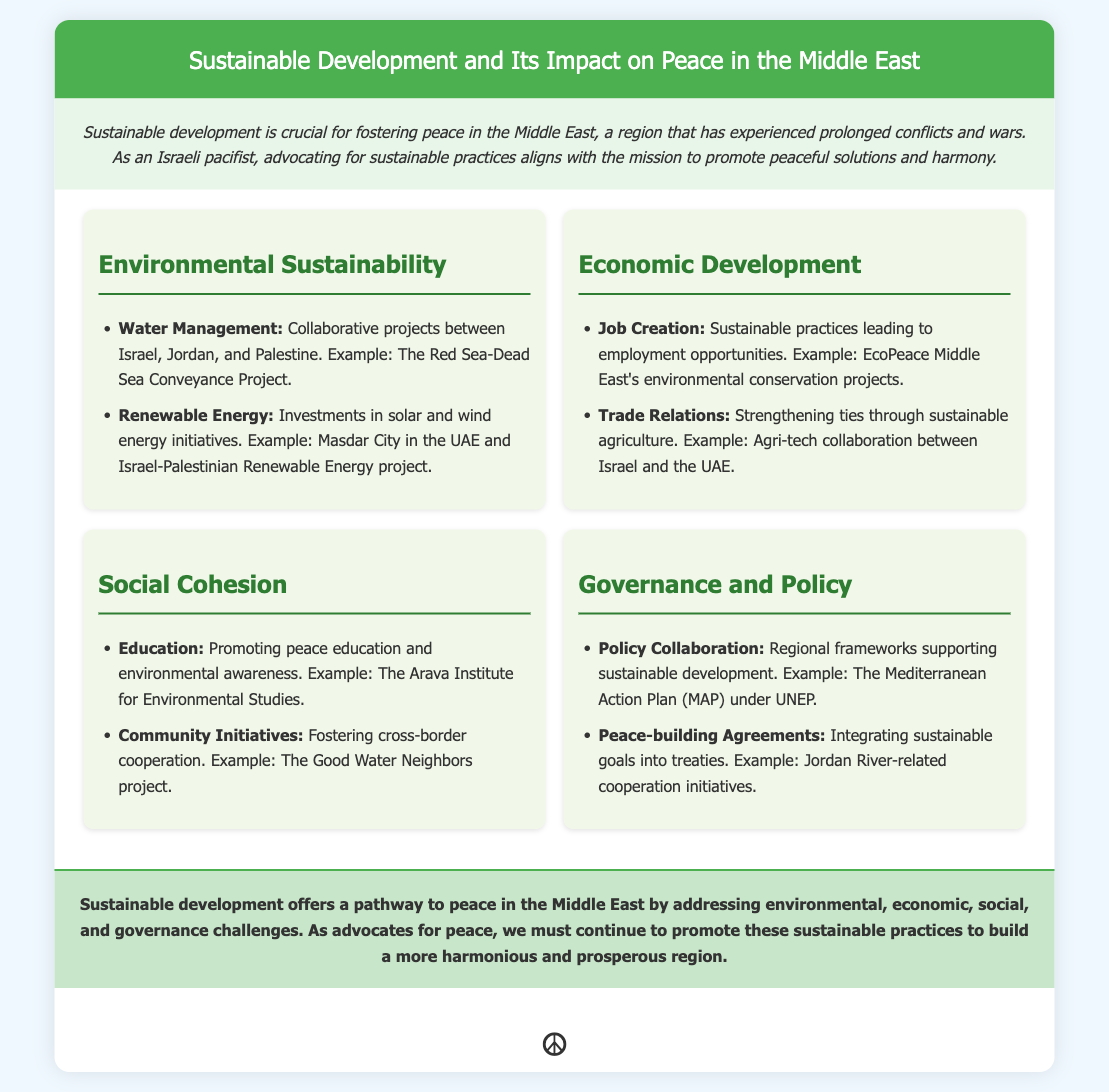What is the title of the presentation? The title of the presentation is clearly stated at the top of the document.
Answer: Sustainable Development and Its Impact on Peace in the Middle East What is one example of a water management project? The presentation lists a specific project under the environmental sustainability section related to water management.
Answer: The Red Sea-Dead Sea Conveyance Project Which renewable energy initiative is mentioned in the document? The document refers to investments in renewable energy initiatives within the environmental sustainability section.
Answer: Masdar City in the UAE What organization is associated with job creation through sustainable practices? The document mentions an organization that focuses on environmental conservation projects that lead to job creation.
Answer: EcoPeace Middle East What type of education does the Arava Institute promote? The presentation highlights an educational focus within the social cohesion section.
Answer: Peace education and environmental awareness What is one of the frameworks supporting sustainable development mentioned? The presentation includes collaboration frameworks under the governance and policy section.
Answer: The Mediterranean Action Plan (MAP) under UNEP How does the document suggest fostering community initiatives? The document provides an example of cross-border cooperation under the social cohesion section.
Answer: The Good Water Neighbors project What is the conclusion's overall message? The conclusion summarizes the document's insights regarding the relationship between sustainable development and peace in the Middle East.
Answer: Sustainable development offers a pathway to peace 